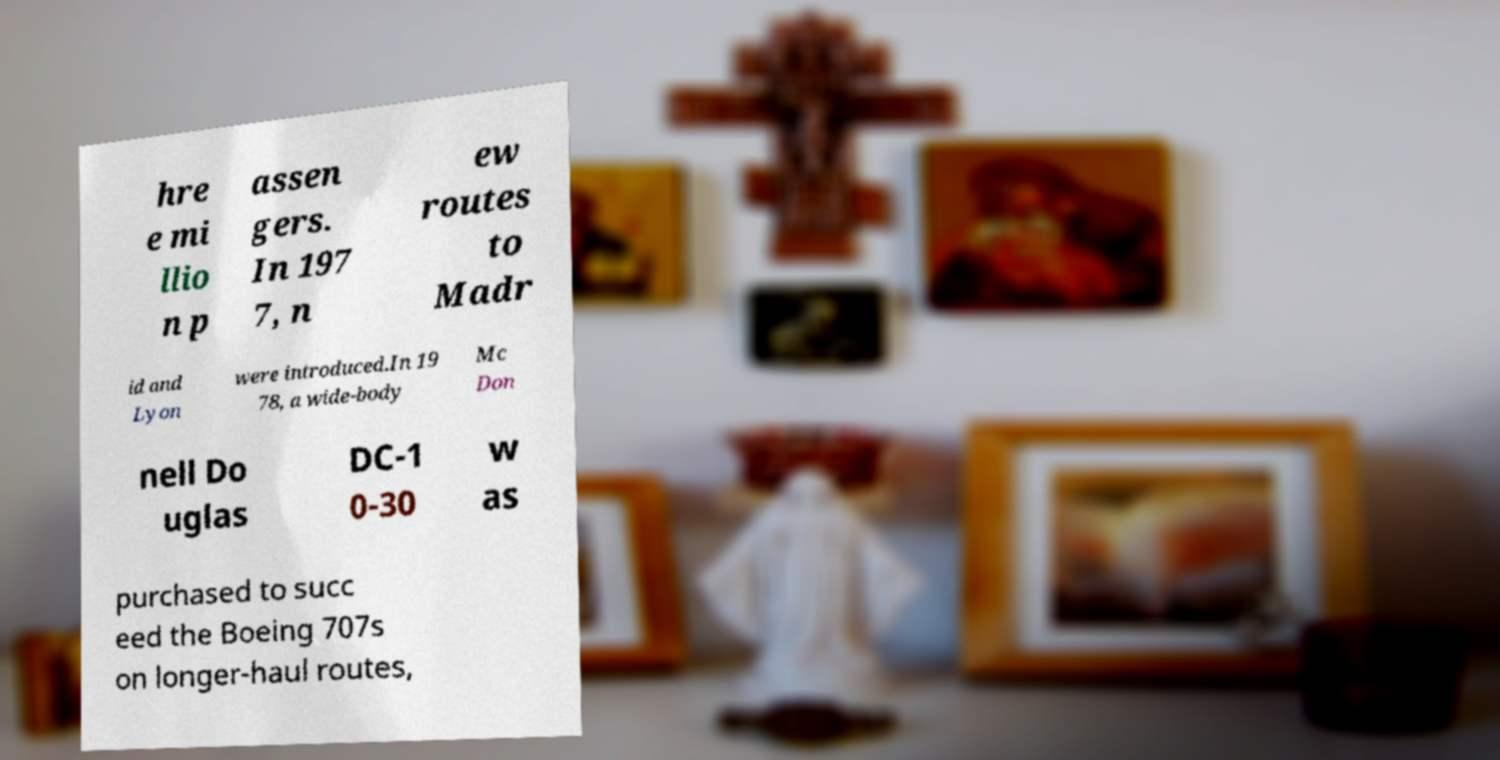Can you read and provide the text displayed in the image?This photo seems to have some interesting text. Can you extract and type it out for me? hre e mi llio n p assen gers. In 197 7, n ew routes to Madr id and Lyon were introduced.In 19 78, a wide-body Mc Don nell Do uglas DC-1 0-30 w as purchased to succ eed the Boeing 707s on longer-haul routes, 